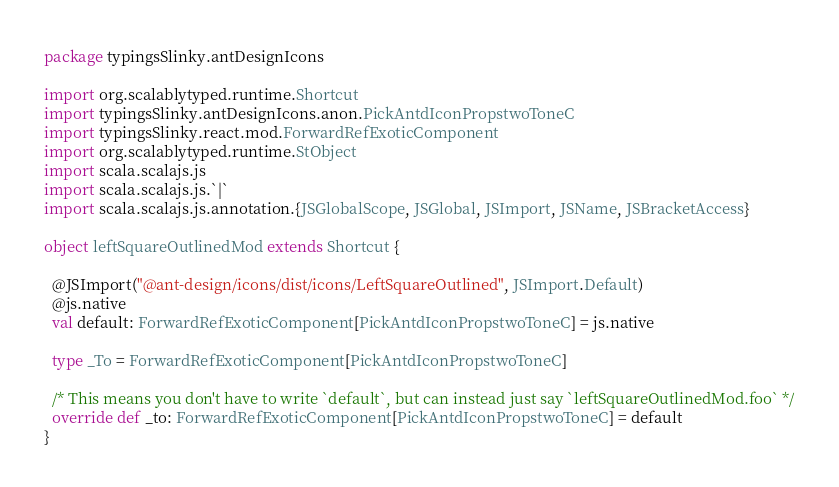Convert code to text. <code><loc_0><loc_0><loc_500><loc_500><_Scala_>package typingsSlinky.antDesignIcons

import org.scalablytyped.runtime.Shortcut
import typingsSlinky.antDesignIcons.anon.PickAntdIconPropstwoToneC
import typingsSlinky.react.mod.ForwardRefExoticComponent
import org.scalablytyped.runtime.StObject
import scala.scalajs.js
import scala.scalajs.js.`|`
import scala.scalajs.js.annotation.{JSGlobalScope, JSGlobal, JSImport, JSName, JSBracketAccess}

object leftSquareOutlinedMod extends Shortcut {
  
  @JSImport("@ant-design/icons/dist/icons/LeftSquareOutlined", JSImport.Default)
  @js.native
  val default: ForwardRefExoticComponent[PickAntdIconPropstwoToneC] = js.native
  
  type _To = ForwardRefExoticComponent[PickAntdIconPropstwoToneC]
  
  /* This means you don't have to write `default`, but can instead just say `leftSquareOutlinedMod.foo` */
  override def _to: ForwardRefExoticComponent[PickAntdIconPropstwoToneC] = default
}
</code> 